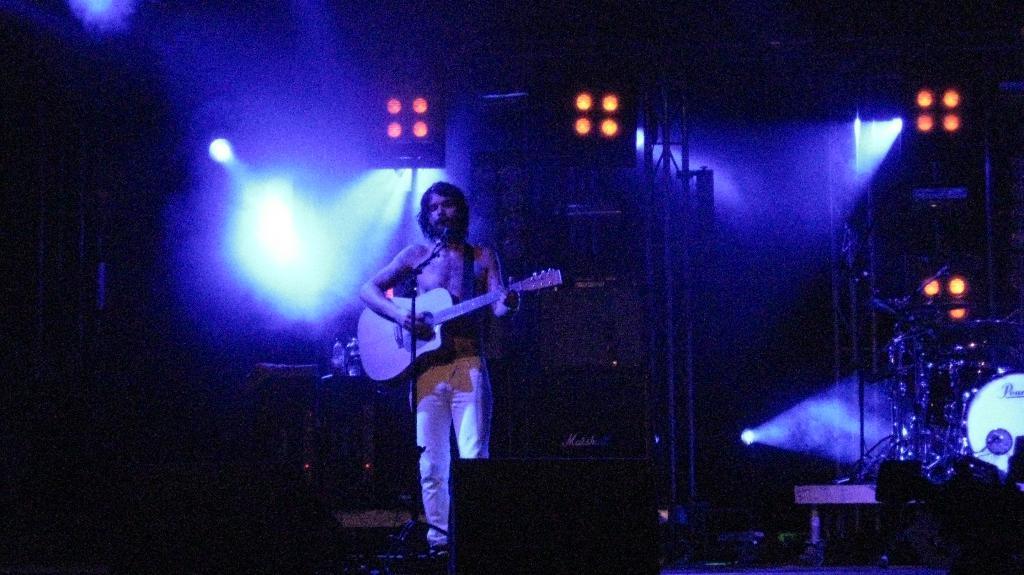Describe this image in one or two sentences. There is a man who is singing on the mike and he is playing guitar. Here we can see some musical instruments. There is a bottle and these are the lights. 